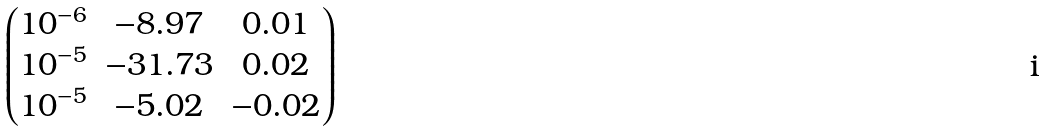Convert formula to latex. <formula><loc_0><loc_0><loc_500><loc_500>\begin{pmatrix} 1 0 ^ { - 6 } & - 8 . 9 7 & 0 . 0 1 \\ 1 0 ^ { - 5 } & - 3 1 . 7 3 & 0 . 0 2 \\ 1 0 ^ { - 5 } & - 5 . 0 2 & - 0 . 0 2 \end{pmatrix}</formula> 